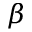Convert formula to latex. <formula><loc_0><loc_0><loc_500><loc_500>\beta</formula> 